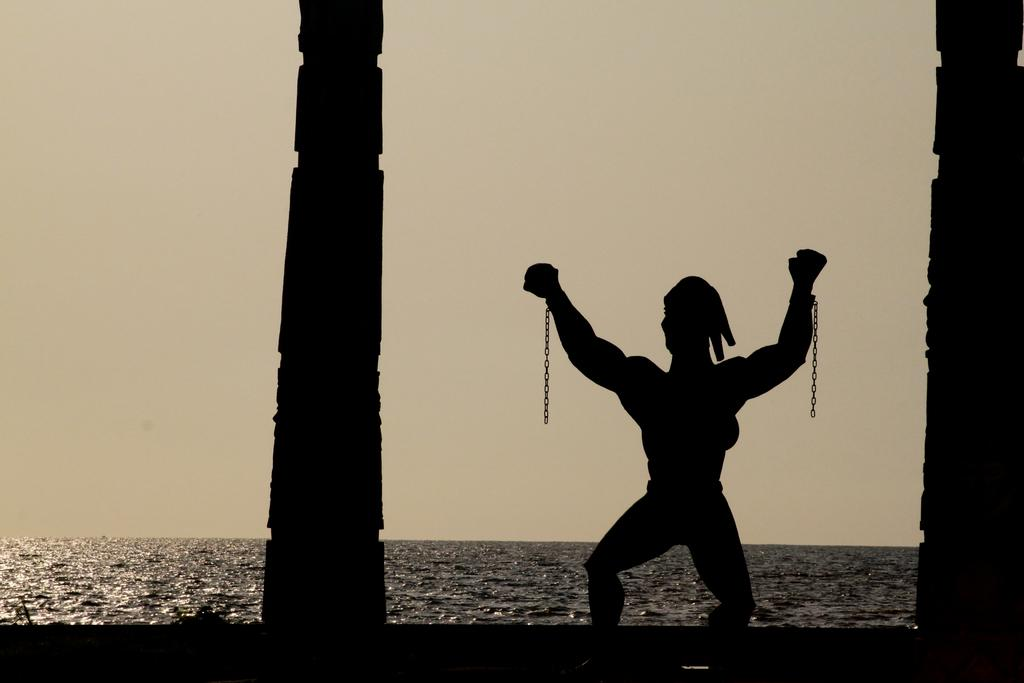What structures can be seen in the foreground of the image? There are pillars in the foreground of the image. What else is present in the foreground besides the pillars? A person resembling a sculpture is present in the foreground. What can be seen in the middle of the image? There is a water body in the middle of the image. What is visible at the top of the image? The sky is visible at the top of the image. How many pockets can be seen on the person in the image? There is no person with pockets present in the image; the person resembling a sculpture does not have any visible pockets. What type of bee can be seen flying around the water body in the image? There are no bees present in the image; it only features pillars, a person resembling a sculpture, a water body, and the sky. 